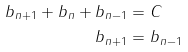Convert formula to latex. <formula><loc_0><loc_0><loc_500><loc_500>b _ { n + 1 } + b _ { n } + b _ { n - 1 } & = C \\ b _ { n + 1 } & = b _ { n - 1 }</formula> 